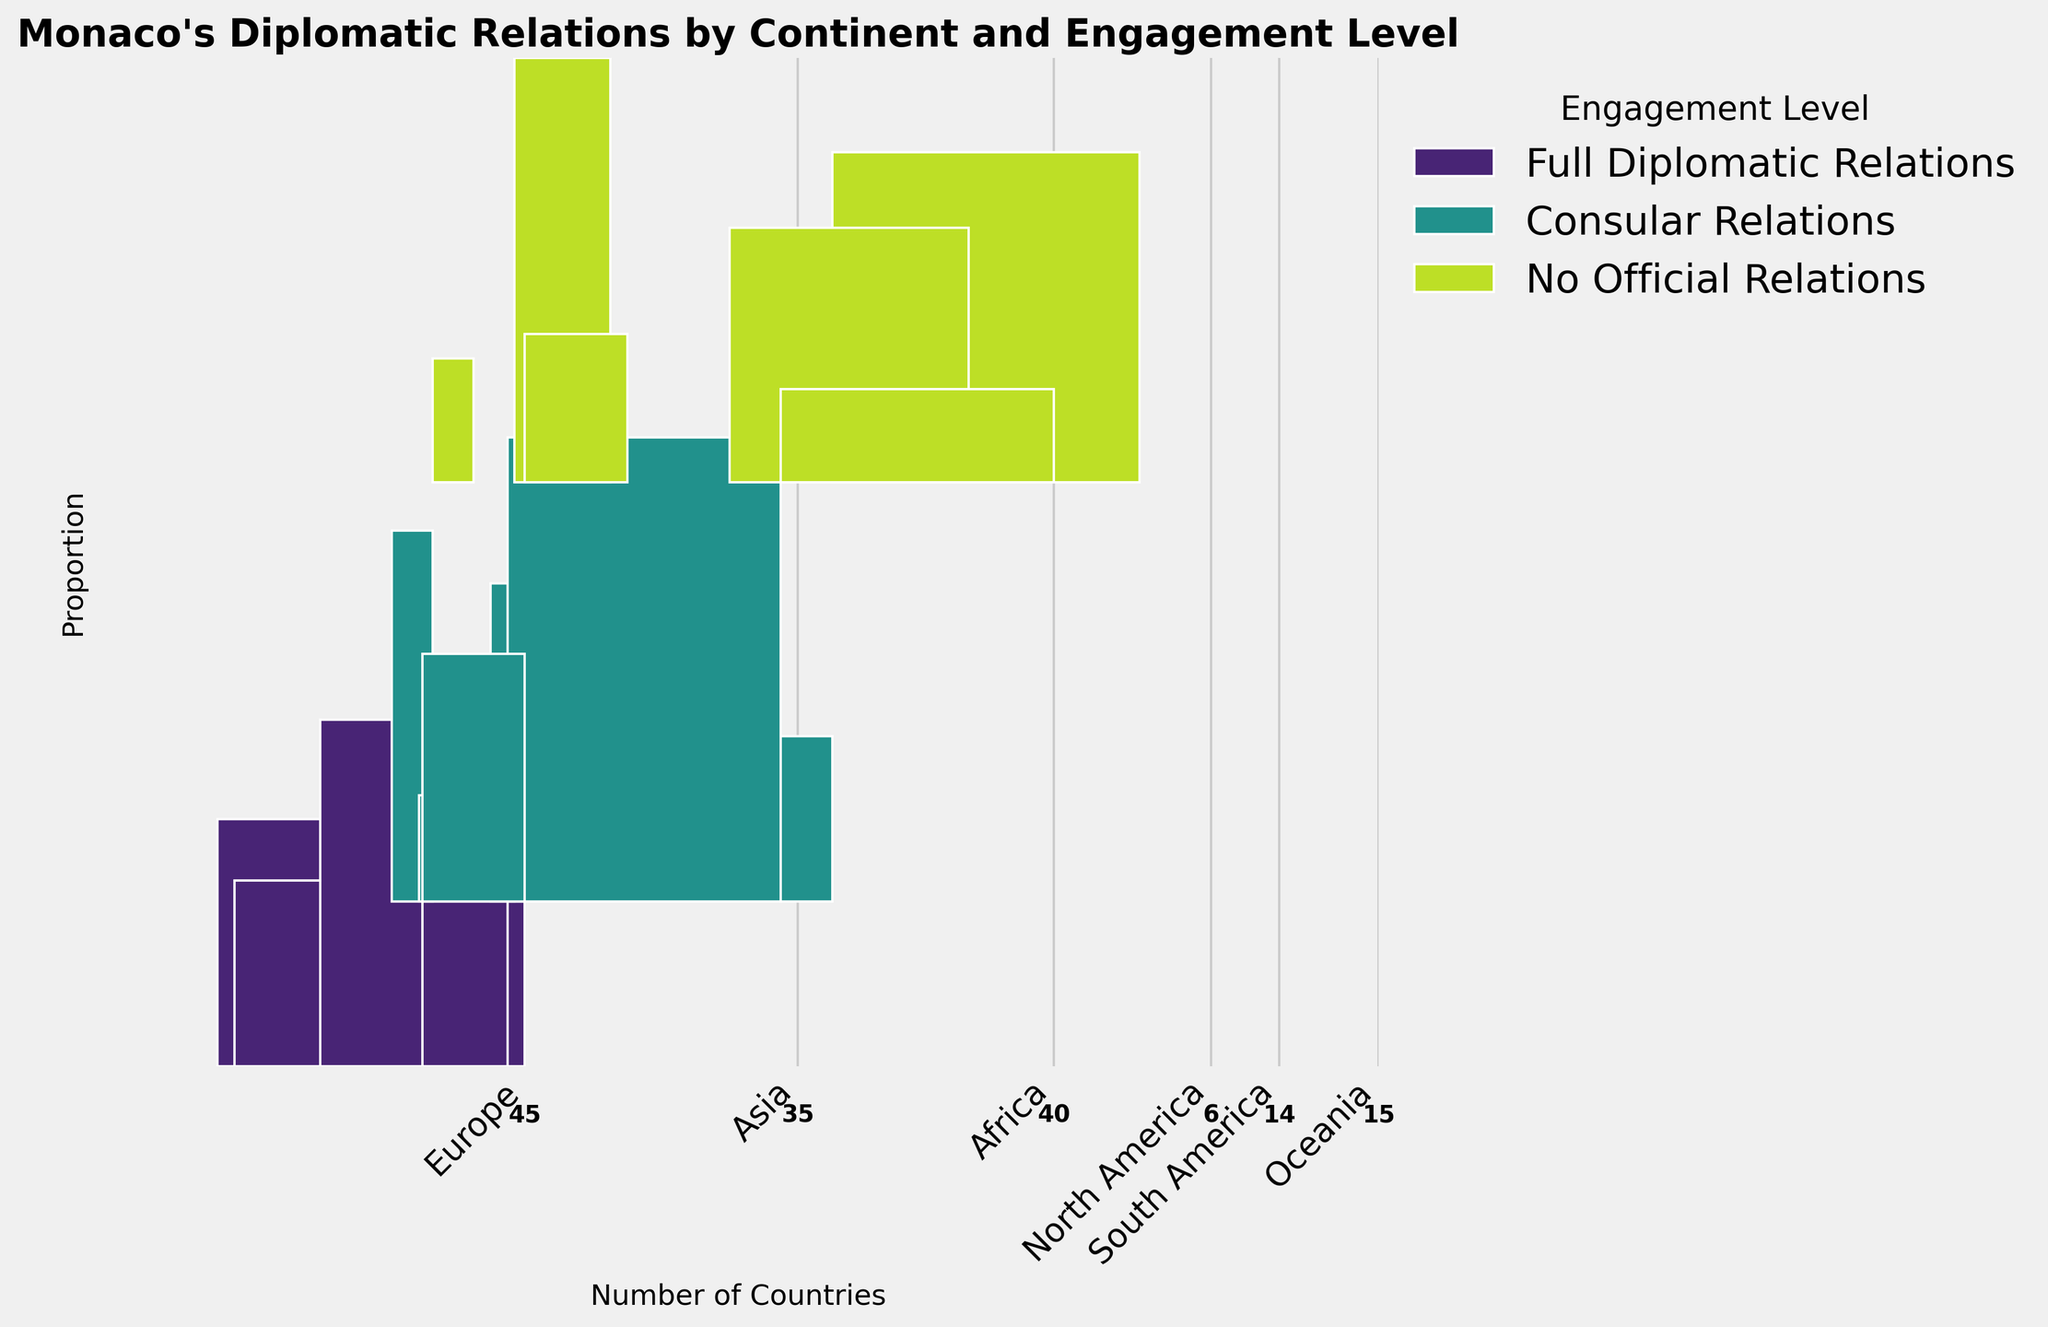What's the title of the figure? The title is written at the top of the figure. It helps to understand the primary focus and topic of the plot.
Answer: Monaco's Diplomatic Relations by Continent and Engagement Level Which continent has the highest number of countries with full diplomatic relations? By looking at the width of the "Full Diplomatic Relations" bar for each continent, Europe has the widest bar, indicating it has the highest number of countries with full diplomatic relations.
Answer: Europe How many countries in Oceania have no official relations with Monaco? The count for "No Official Relations" is labeled at the bottom of the bar representing Oceania.
Answer: 8 What is the proportion of countries with consular relations to the total number of countries in Africa? Find the height of the "Consular Relations" part of the bar for Africa. The relation part covers more than half of the total bar for Africa. It's indicated visually by a significant height difference. Then, calculate the ratio using the corresponding height in the mosaic plot.
Answer: 15 out of 45 (1/3) If you sum the number of countries with full diplomatic and consular relations in South America, what do you get? Sum the two relevant numbers from the plot: Full Diplomatic Relations (5) + Consular Relations (7).
Answer: 12 Which engagement level has the least number of countries across all continents? Compare the heights of each engagement level color segment across all bars in the mosaic plot. "No Official Relations" in North America is the least.
Answer: No Official Relations (North America) Compare the number of countries with consular relations in Asia and Africa. Which is higher? Compare the heights of the "Consular Relations" bar segments for both Asia (shorter) and Africa (taller).
Answer: Africa What total number of countries accounts for the North American continent in this diplomatic relation overview? Sum all the portions of the bar related to North America: 3 (Full Diplomatic Relations) + 2 (Consular Relations) + 1 (No Official Relations).
Answer: 6 Considering all continents, which engagement level seems to have the most substantial number of countries? The visual height and width distinction between engagement levels across continents show "Full Diplomatic Relations" generally have the broadest height coverage.
Answer: Full Diplomatic Relations Which continent has the smallest total number of countries engaged with Monaco? Determine by analyzing the width of each continent's bar: Oceania has the thinnest width.
Answer: Oceania 